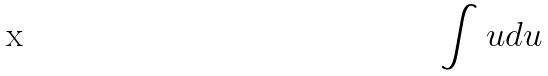<formula> <loc_0><loc_0><loc_500><loc_500>\int u d u</formula> 